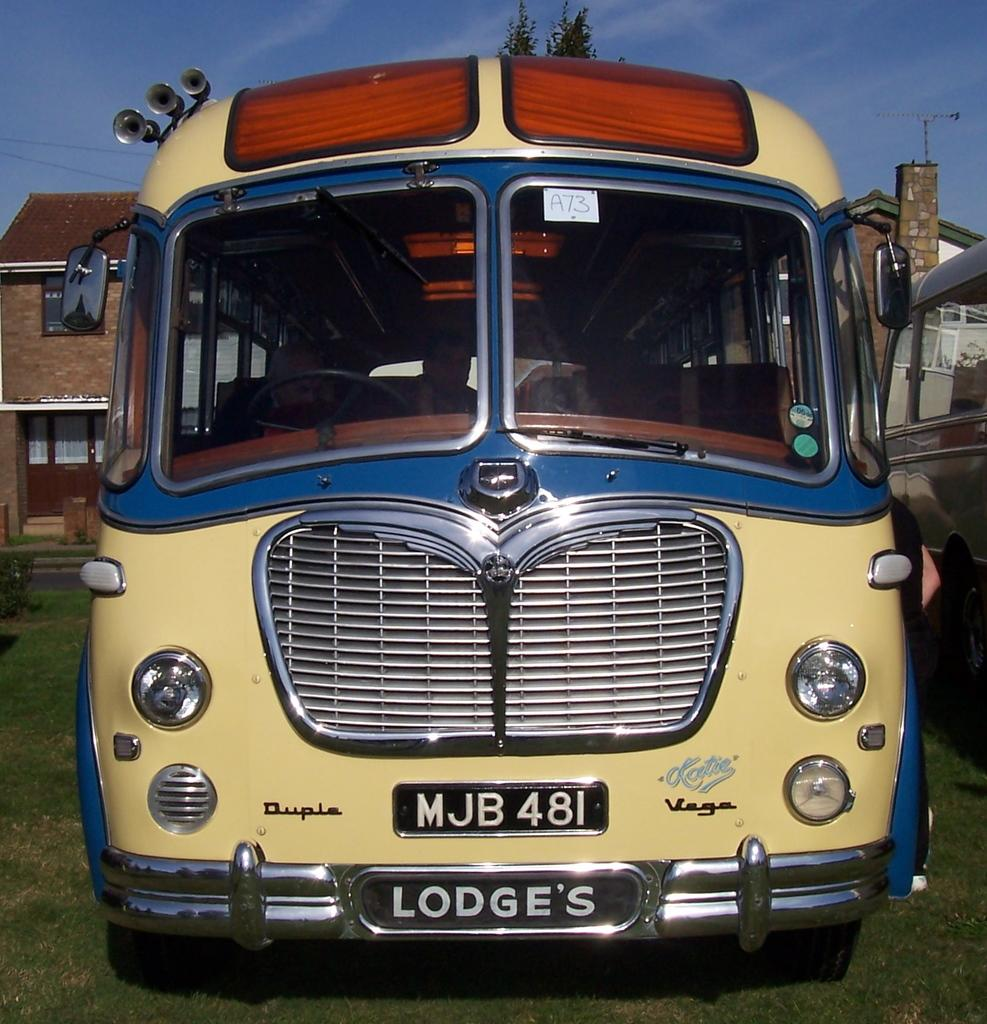What is the main subject of the image? The main subject of the image is a bus. What can be seen on the bus? The bus has a number plate and windows. What is visible in the background of the image? There is a building, the sky, and a tree in the background of the image. What type of oil is being used to lubricate the wheels of the bus in the image? There is no information about oil or the wheels of the bus in the image, so we cannot determine what type of oil is being used. 